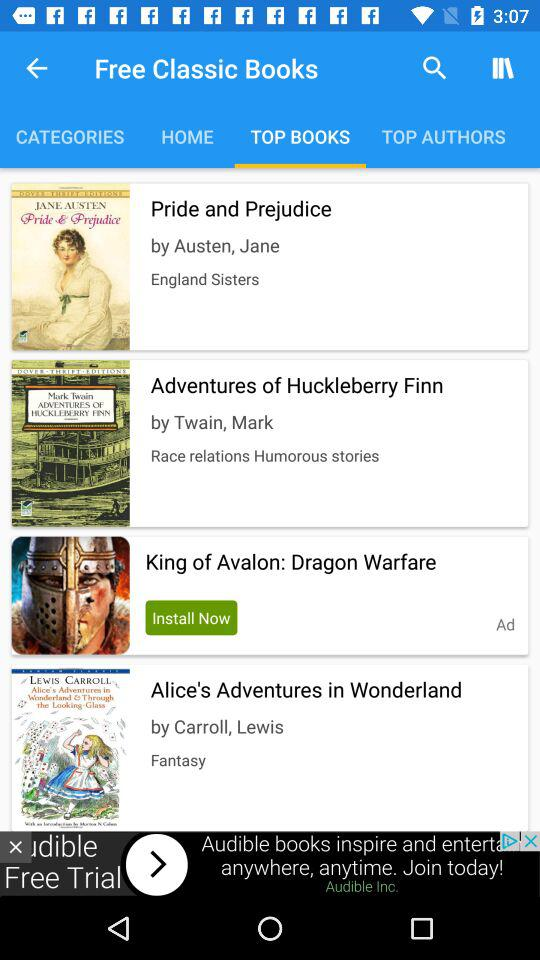What is the title of the book written by Austen, Jane? The title of the book is "Pride and Prejudice". 